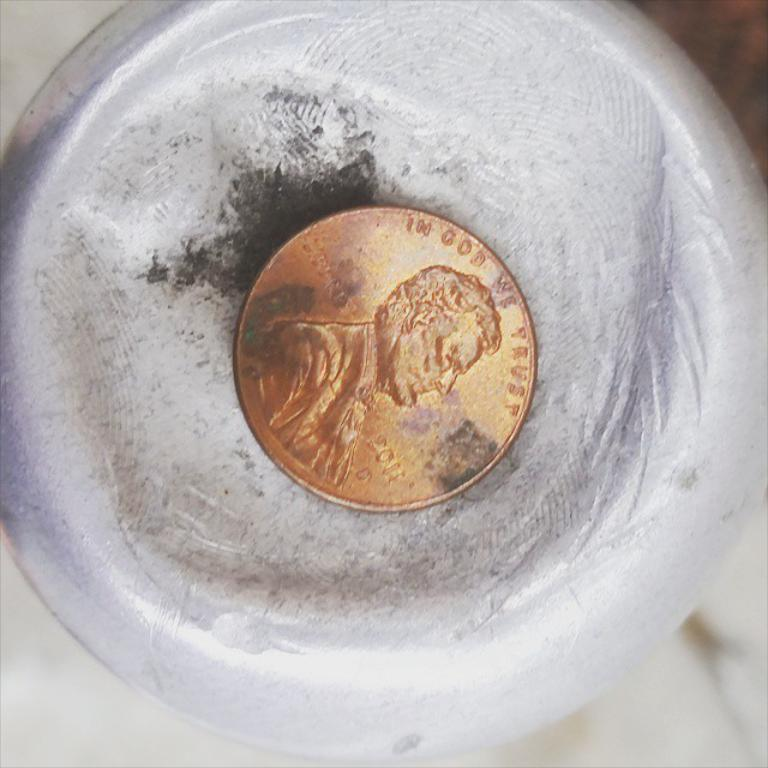What is present inside the object in the image? There is a coin in an object in the image. Can you describe the background of the image? The background of the image is blurry. How many dogs are visible in the image? There are no dogs present in the image. What type of base is supporting the object with the coin? The provided facts do not mention a base supporting the object with the coin. 